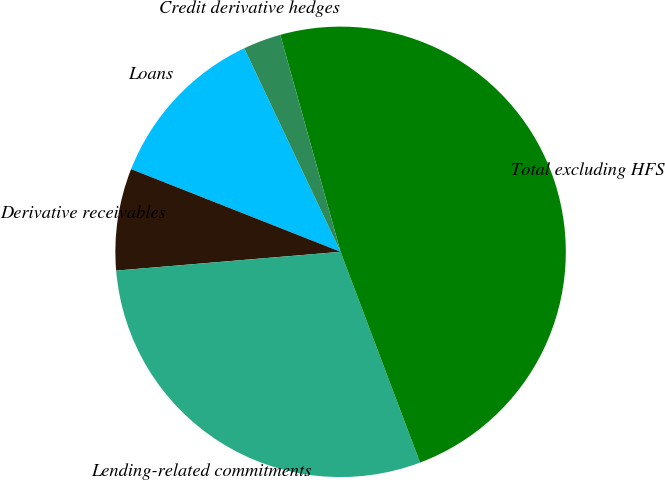<chart> <loc_0><loc_0><loc_500><loc_500><pie_chart><fcel>Loans<fcel>Derivative receivables<fcel>Lending-related commitments<fcel>Total excluding HFS<fcel>Credit derivative hedges<nl><fcel>11.98%<fcel>7.31%<fcel>29.41%<fcel>48.57%<fcel>2.72%<nl></chart> 